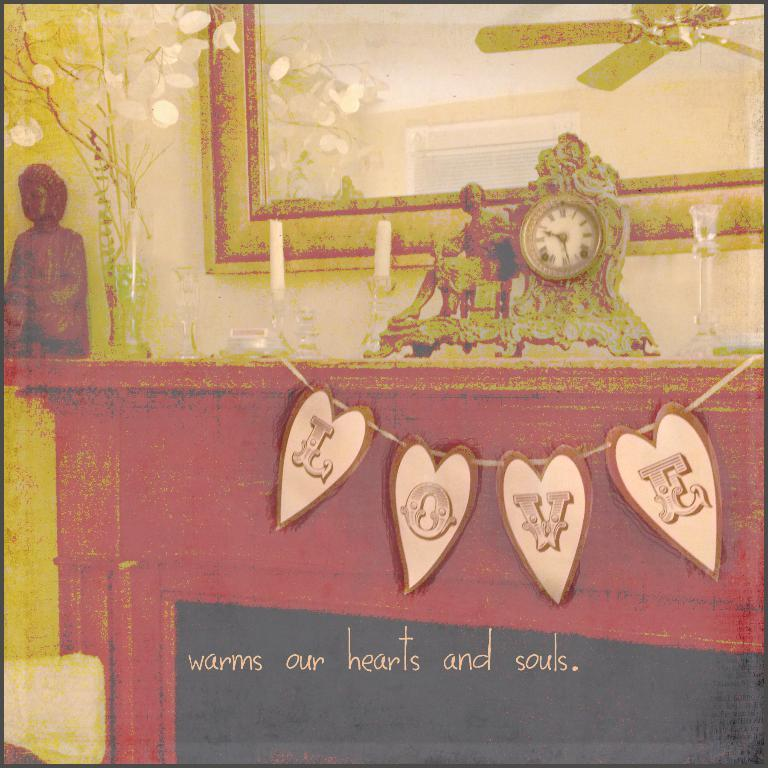<image>
Share a concise interpretation of the image provided. Love sign that warms our hearts and souls on the entertainment center 